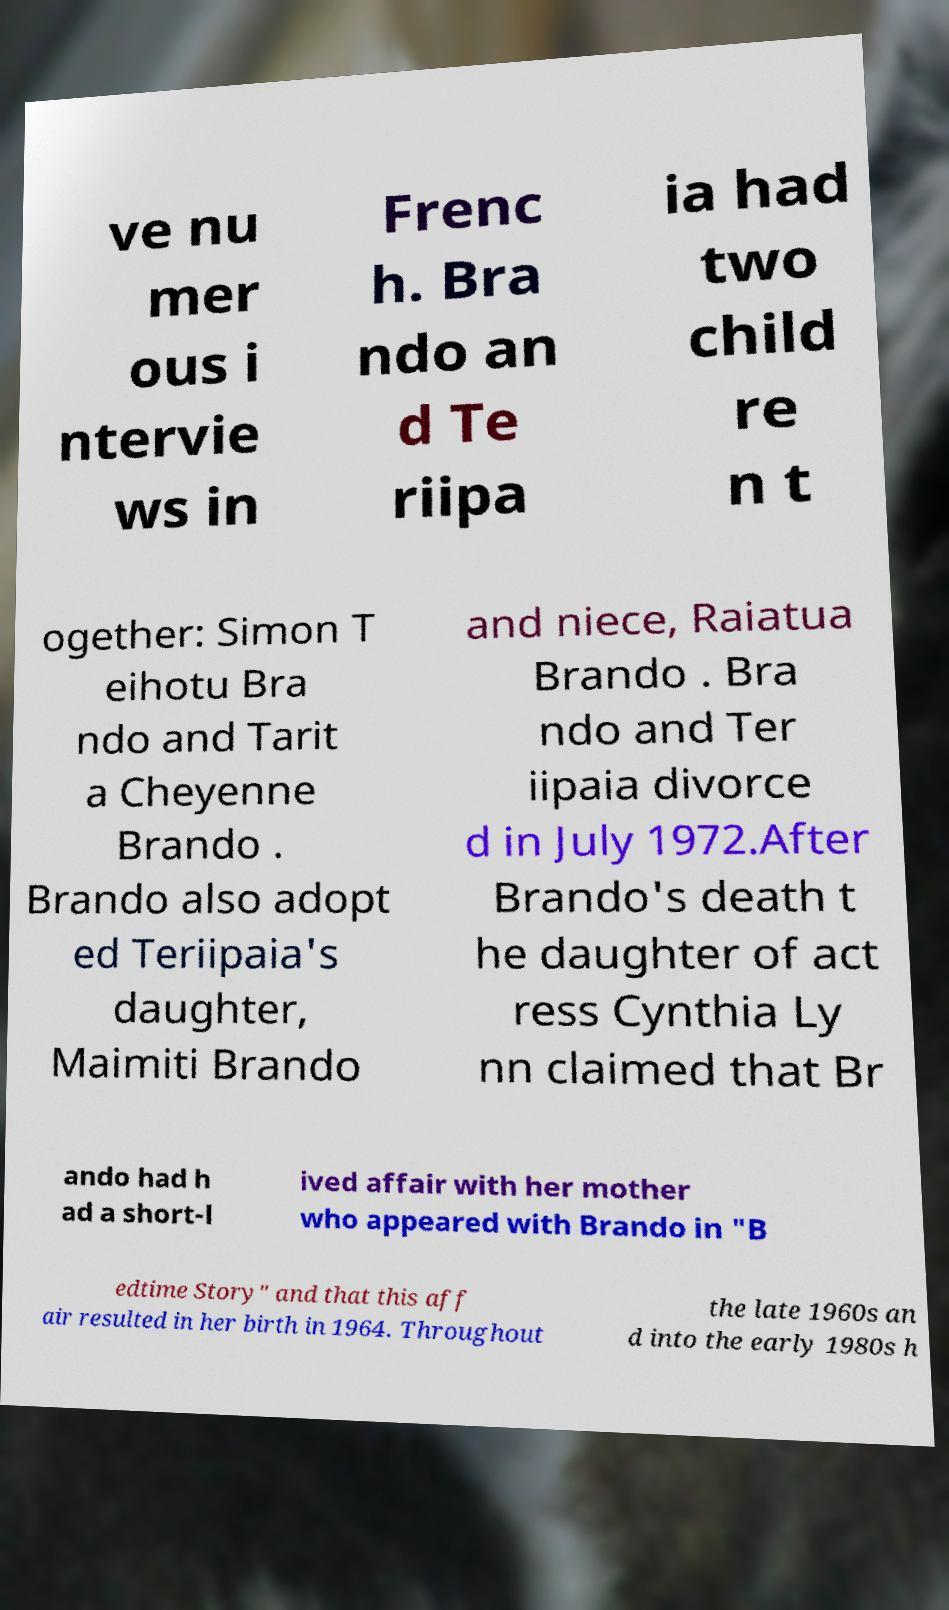I need the written content from this picture converted into text. Can you do that? ve nu mer ous i ntervie ws in Frenc h. Bra ndo an d Te riipa ia had two child re n t ogether: Simon T eihotu Bra ndo and Tarit a Cheyenne Brando . Brando also adopt ed Teriipaia's daughter, Maimiti Brando and niece, Raiatua Brando . Bra ndo and Ter iipaia divorce d in July 1972.After Brando's death t he daughter of act ress Cynthia Ly nn claimed that Br ando had h ad a short-l ived affair with her mother who appeared with Brando in "B edtime Story" and that this aff air resulted in her birth in 1964. Throughout the late 1960s an d into the early 1980s h 